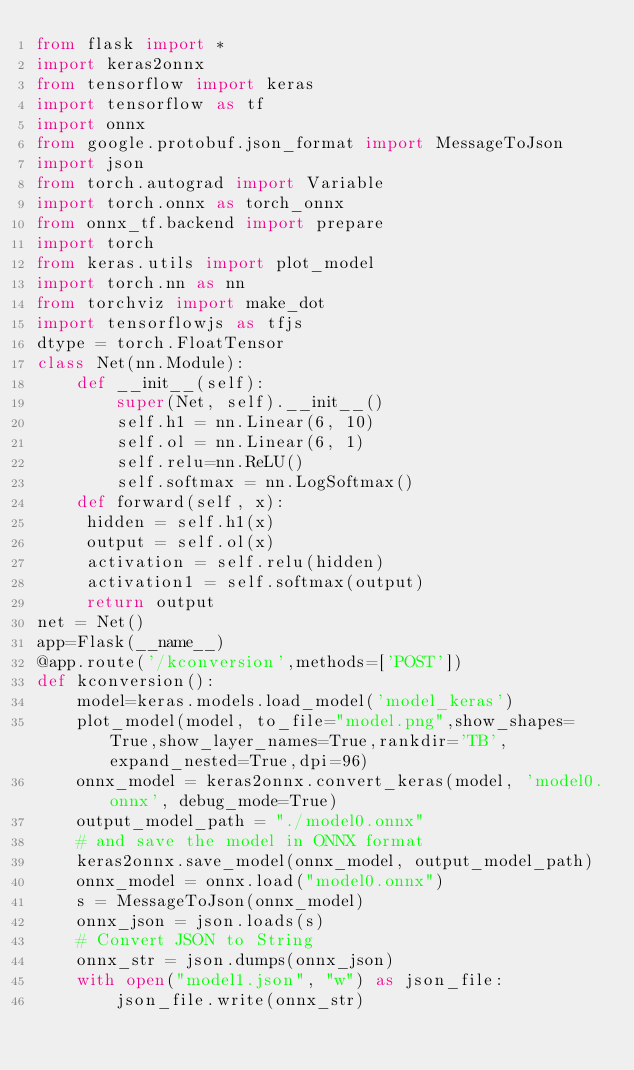<code> <loc_0><loc_0><loc_500><loc_500><_Python_>from flask import *
import keras2onnx
from tensorflow import keras
import tensorflow as tf
import onnx
from google.protobuf.json_format import MessageToJson
import json
from torch.autograd import Variable
import torch.onnx as torch_onnx
from onnx_tf.backend import prepare
import torch
from keras.utils import plot_model
import torch.nn as nn
from torchviz import make_dot
import tensorflowjs as tfjs
dtype = torch.FloatTensor
class Net(nn.Module):
    def __init__(self):
        super(Net, self).__init__()
        self.h1 = nn.Linear(6, 10)
        self.ol = nn.Linear(6, 1)
        self.relu=nn.ReLU()
        self.softmax = nn.LogSoftmax()
    def forward(self, x):
     hidden = self.h1(x)
     output = self.ol(x)
     activation = self.relu(hidden)
     activation1 = self.softmax(output)
     return output
net = Net()
app=Flask(__name__)
@app.route('/kconversion',methods=['POST'])
def kconversion():
    model=keras.models.load_model('model_keras')
    plot_model(model, to_file="model.png",show_shapes=True,show_layer_names=True,rankdir='TB',expand_nested=True,dpi=96)
    onnx_model = keras2onnx.convert_keras(model, 'model0.onnx', debug_mode=True)
    output_model_path = "./model0.onnx"
    # and save the model in ONNX format
    keras2onnx.save_model(onnx_model, output_model_path)
    onnx_model = onnx.load("model0.onnx")
    s = MessageToJson(onnx_model)
    onnx_json = json.loads(s)
    # Convert JSON to String
    onnx_str = json.dumps(onnx_json)
    with open("model1.json", "w") as json_file:
        json_file.write(onnx_str)</code> 